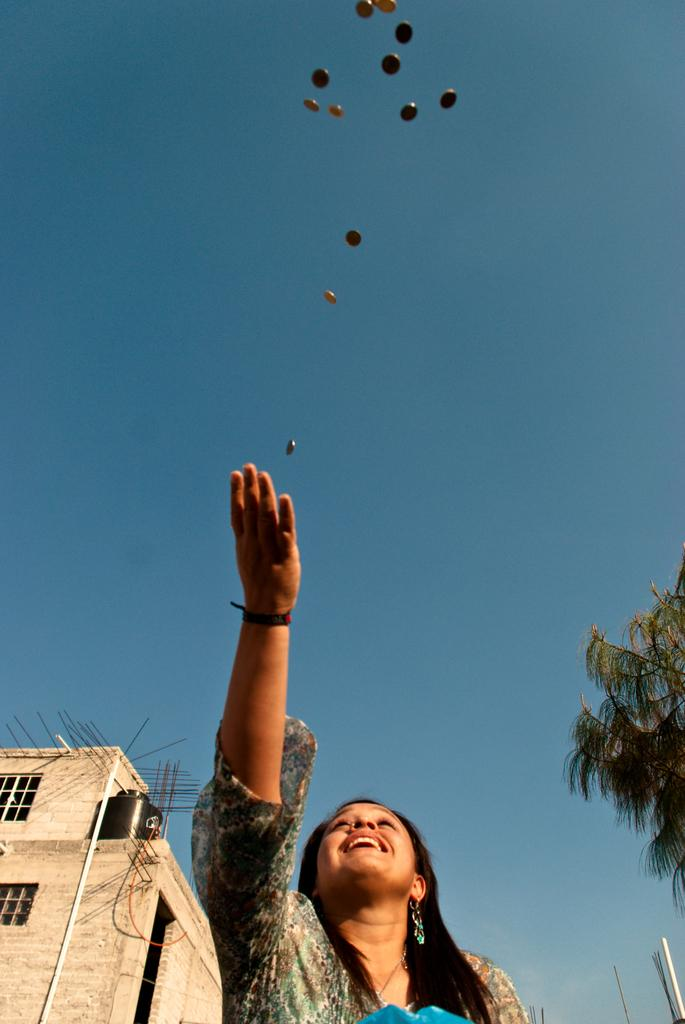Who is present in the image? There is a woman in the picture. What is the woman's expression? The woman is smiling. What is happening with the coins in the image? There are coins in the air. What can be seen on the left side of the image? There is a building on the left side of the image. What type of vegetation is on the right side of the image? There is a tree on the right side of the image. What is the condition of the sky in the image? The sky is clear in the image. How does the woman plan to increase the speed of the railway in the image? There is no railway present in the image, so it is not possible to discuss increasing its speed. 